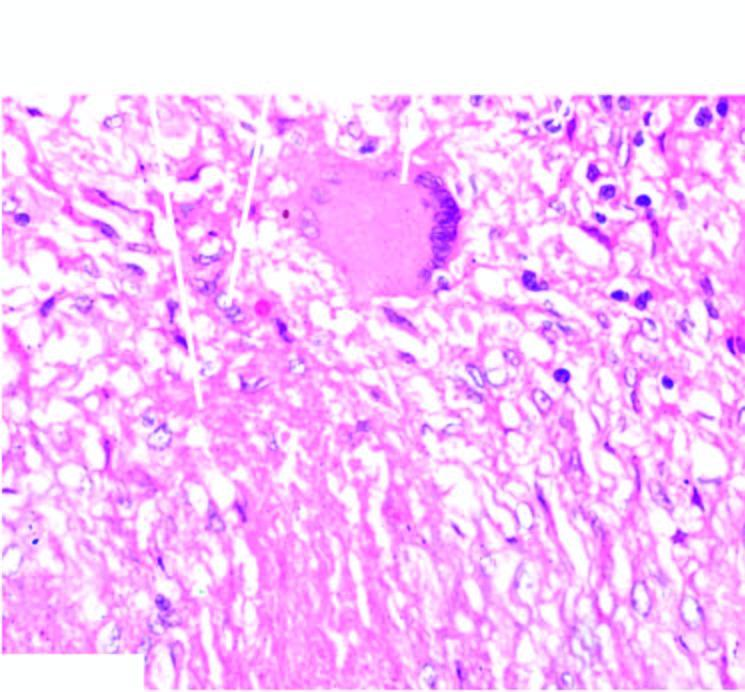does the colour of sectioned surface show lymphocytes?
Answer the question using a single word or phrase. No 